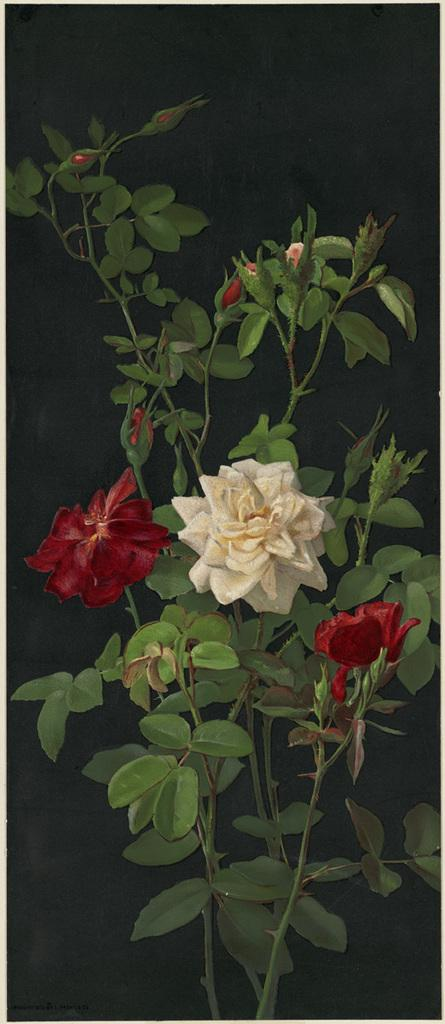What type of living organism can be seen in the image? There is a plant in the image. What specific part of the plant is visible in the image? There are flowers in the image. How would you describe the overall appearance of the image? The background of the image is dark. What type of mark can be seen on the quilt in the image? There is no quilt present in the image, so it is not possible to determine if there is a mark on it. 